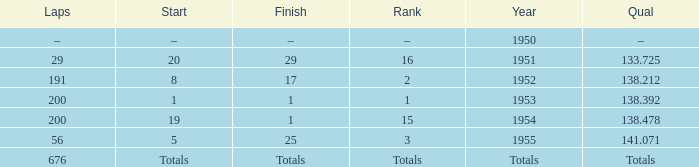How many laps does the one ranked 16 have? 29.0. 